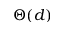Convert formula to latex. <formula><loc_0><loc_0><loc_500><loc_500>\Theta ( d )</formula> 